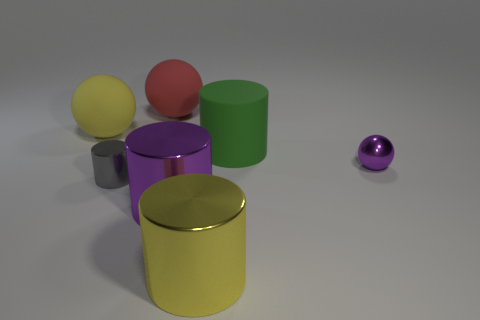Is the number of green cylinders to the right of the purple metallic ball less than the number of large matte balls that are behind the yellow rubber thing?
Your answer should be very brief. Yes. There is a small purple metal object that is in front of the large green object; is it the same shape as the big yellow object behind the large yellow shiny object?
Give a very brief answer. Yes. There is a large yellow object in front of the green thing behind the tiny cylinder; what is its shape?
Make the answer very short. Cylinder. Are there any big purple things made of the same material as the small cylinder?
Offer a terse response. Yes. What is the material of the yellow object to the right of the big yellow rubber thing?
Provide a short and direct response. Metal. What material is the gray object?
Provide a short and direct response. Metal. Does the big yellow object that is behind the big purple object have the same material as the red thing?
Offer a very short reply. Yes. Are there fewer small metallic cylinders that are behind the red rubber ball than tiny purple things?
Your answer should be very brief. Yes. There is another matte sphere that is the same size as the red rubber ball; what color is it?
Offer a terse response. Yellow. What number of other things are the same shape as the big green rubber thing?
Your answer should be compact. 3. 